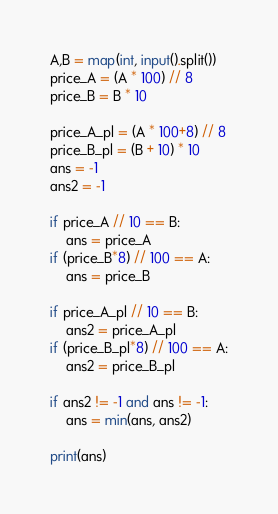<code> <loc_0><loc_0><loc_500><loc_500><_Python_>A,B = map(int, input().split())
price_A = (A * 100) // 8
price_B = B * 10

price_A_pl = (A * 100+8) // 8
price_B_pl = (B + 10) * 10
ans = -1
ans2 = -1

if price_A // 10 == B:
    ans = price_A
if (price_B*8) // 100 == A:
    ans = price_B
    
if price_A_pl // 10 == B:
    ans2 = price_A_pl
if (price_B_pl*8) // 100 == A:
    ans2 = price_B_pl

if ans2 != -1 and ans != -1:
    ans = min(ans, ans2)

print(ans)</code> 